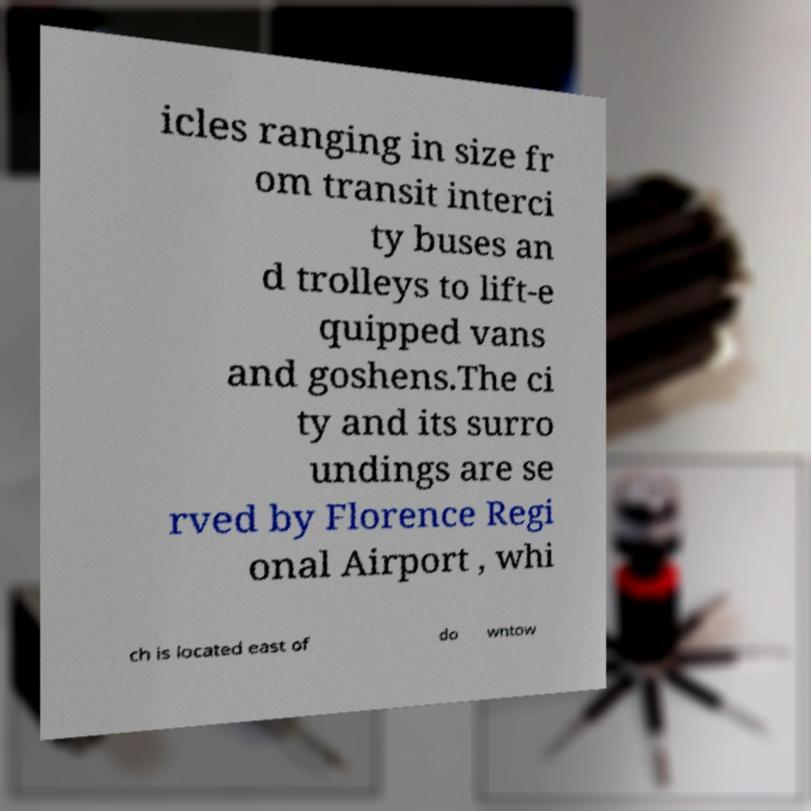Please identify and transcribe the text found in this image. icles ranging in size fr om transit interci ty buses an d trolleys to lift-e quipped vans and goshens.The ci ty and its surro undings are se rved by Florence Regi onal Airport , whi ch is located east of do wntow 